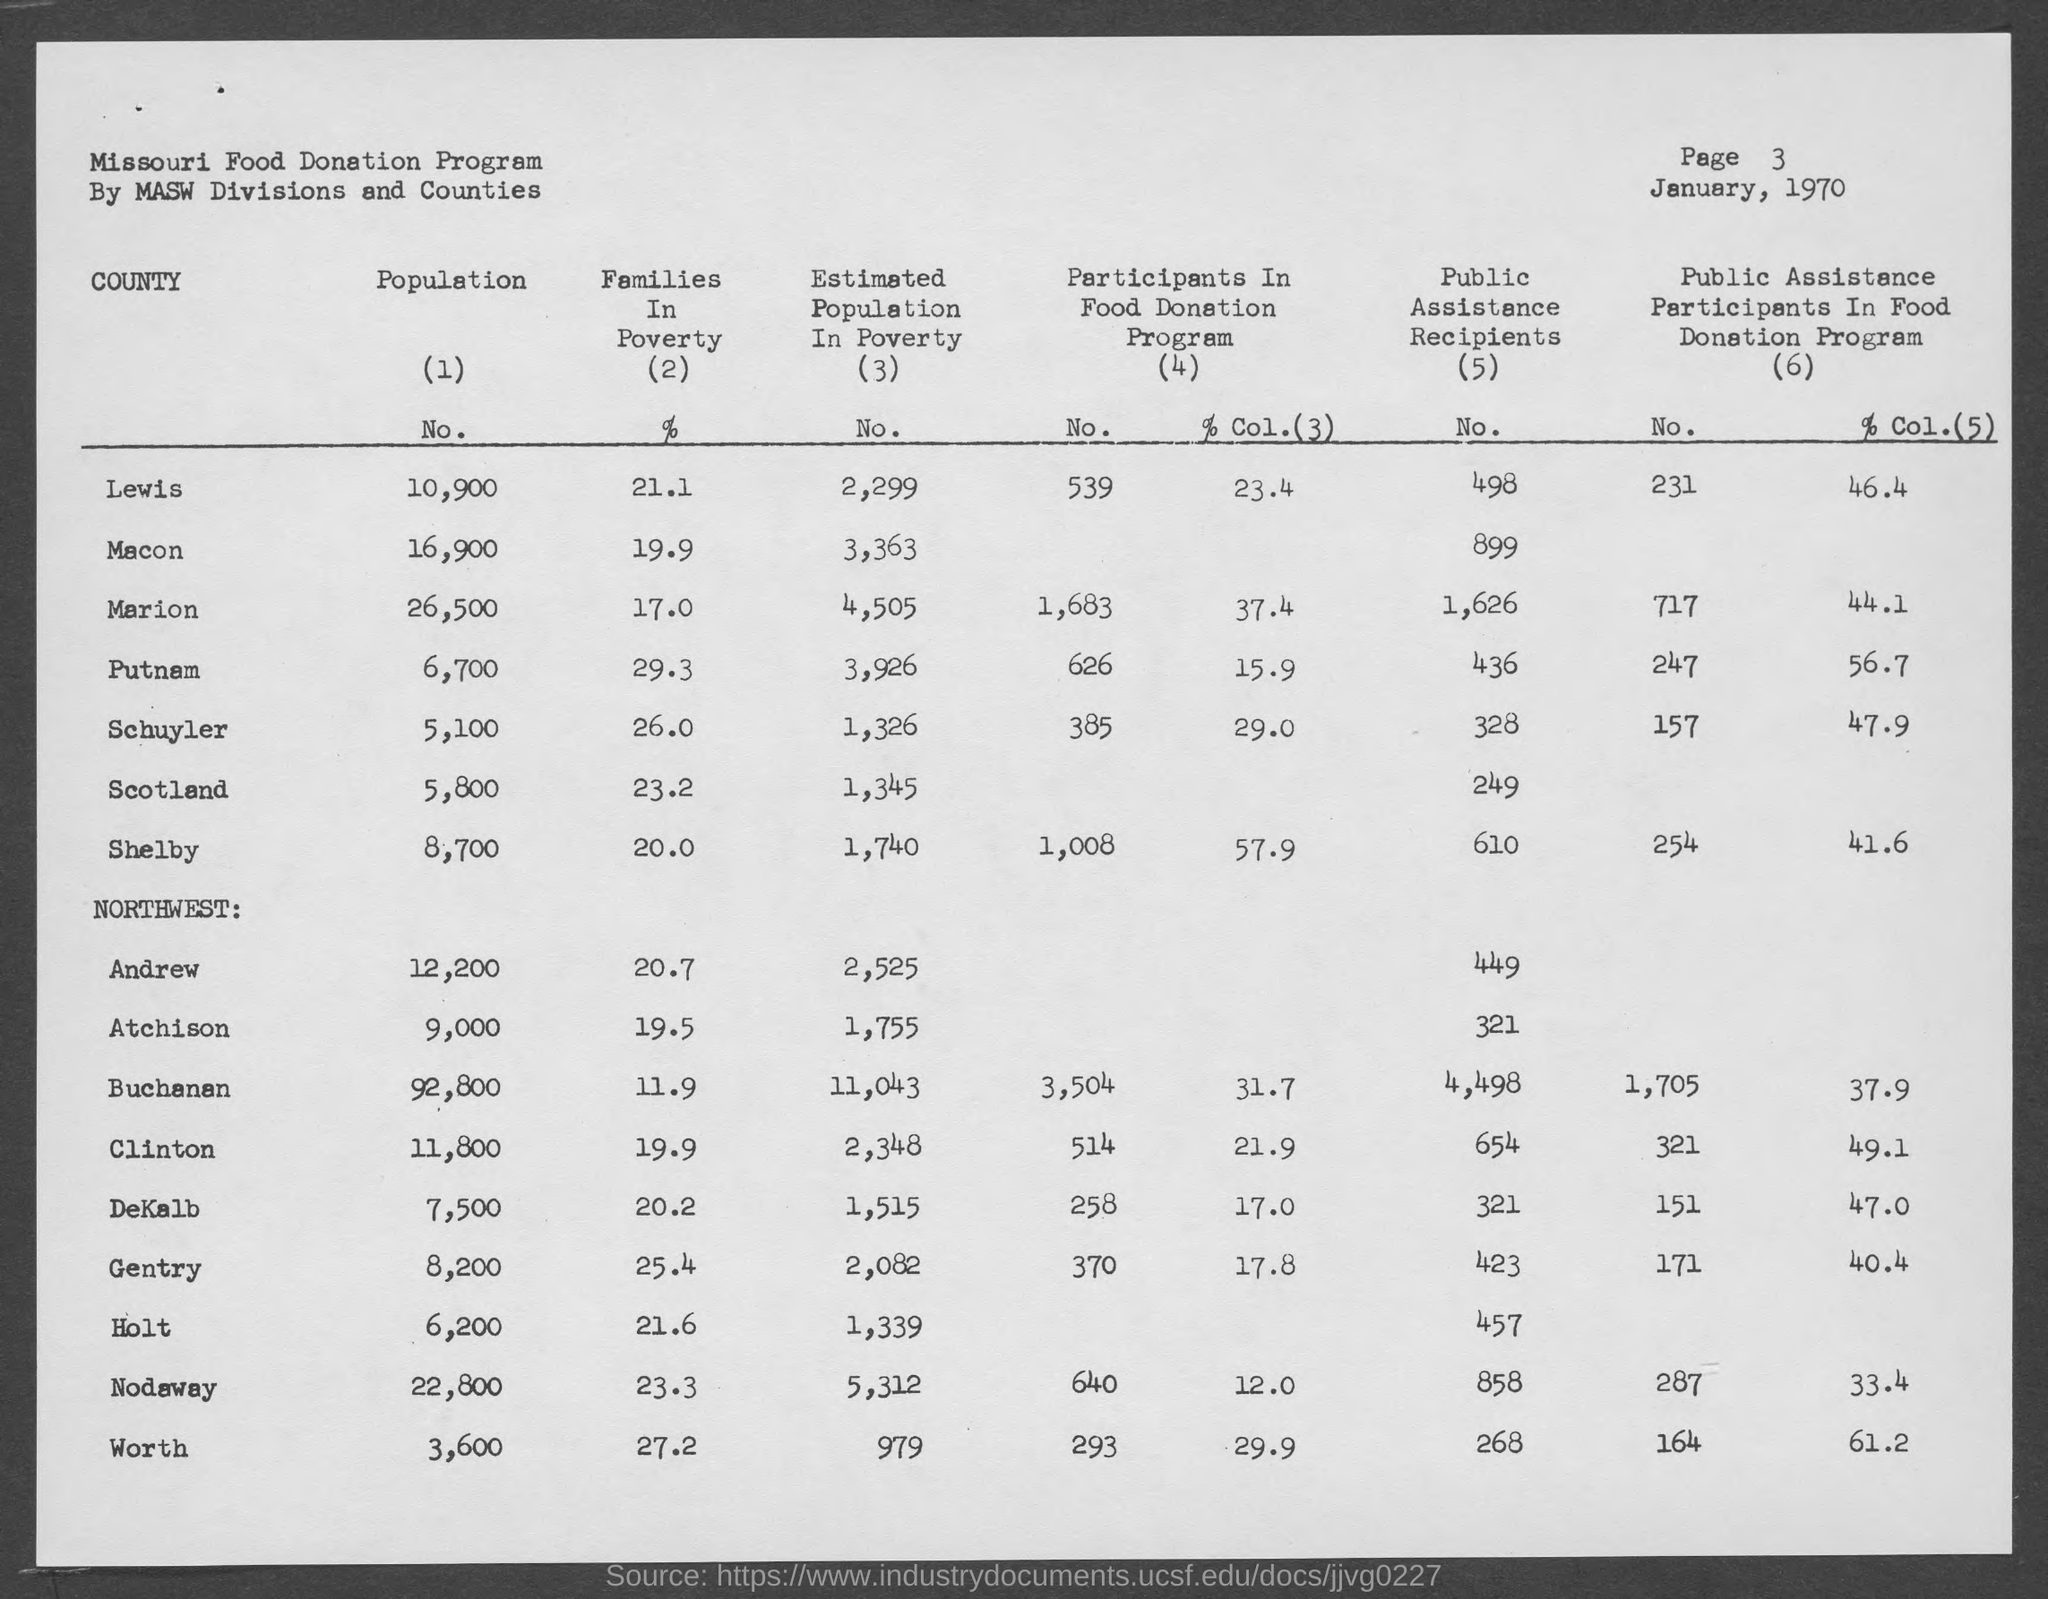Point out several critical features in this image. The estimated population in poverty in Andrew County is approximately 2,525 people. The estimated population in poverty in Marion County is 4,505. According to estimates, the population in poverty in Macon County is approximately 3,363. The estimated population living in poverty in Shelby is approximately 1,740 people. The month and year at the top of the page are January 1970. 